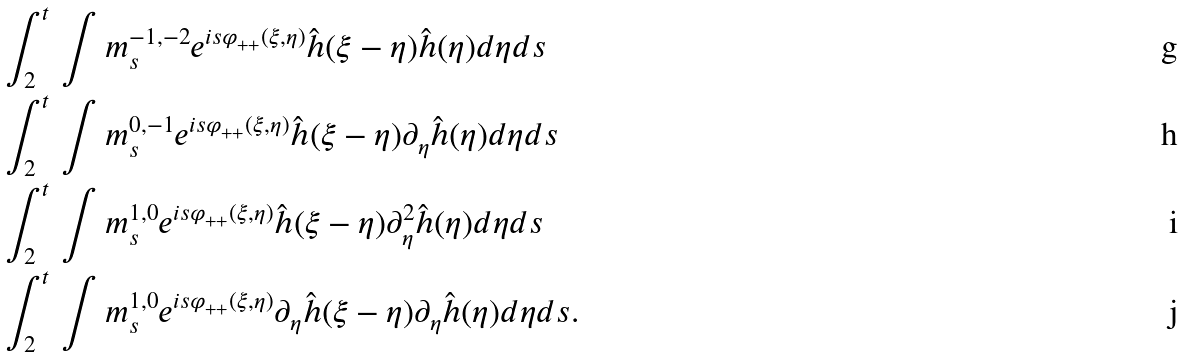Convert formula to latex. <formula><loc_0><loc_0><loc_500><loc_500>& \int _ { 2 } ^ { t } \, \int m ^ { - 1 , - 2 } _ { s } e ^ { i s \varphi _ { + + } ( \xi , \eta ) } \hat { h } ( \xi - \eta ) \hat { h } ( \eta ) d \eta d s \\ & \int _ { 2 } ^ { t } \, \int m ^ { 0 , - 1 } _ { s } e ^ { i s \varphi _ { + + } ( \xi , \eta ) } \hat { h } ( \xi - \eta ) \partial _ { \eta } \hat { h } ( \eta ) d \eta d s \\ & \int _ { 2 } ^ { t } \, \int m ^ { 1 , 0 } _ { s } e ^ { i s \varphi _ { + + } ( \xi , \eta ) } \hat { h } ( \xi - \eta ) \partial _ { \eta } ^ { 2 } \hat { h } ( \eta ) d \eta d s \\ & \int _ { 2 } ^ { t } \, \int m ^ { 1 , 0 } _ { s } e ^ { i s \varphi _ { + + } ( \xi , \eta ) } \partial _ { \eta } \hat { h } ( \xi - \eta ) \partial _ { \eta } \hat { h } ( \eta ) d \eta d s .</formula> 